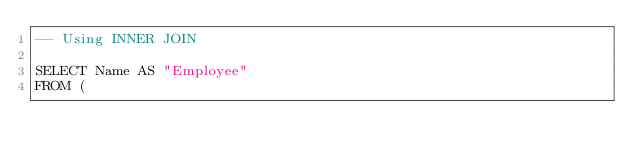<code> <loc_0><loc_0><loc_500><loc_500><_SQL_>-- Using INNER JOIN

SELECT Name AS "Employee"
FROM (</code> 